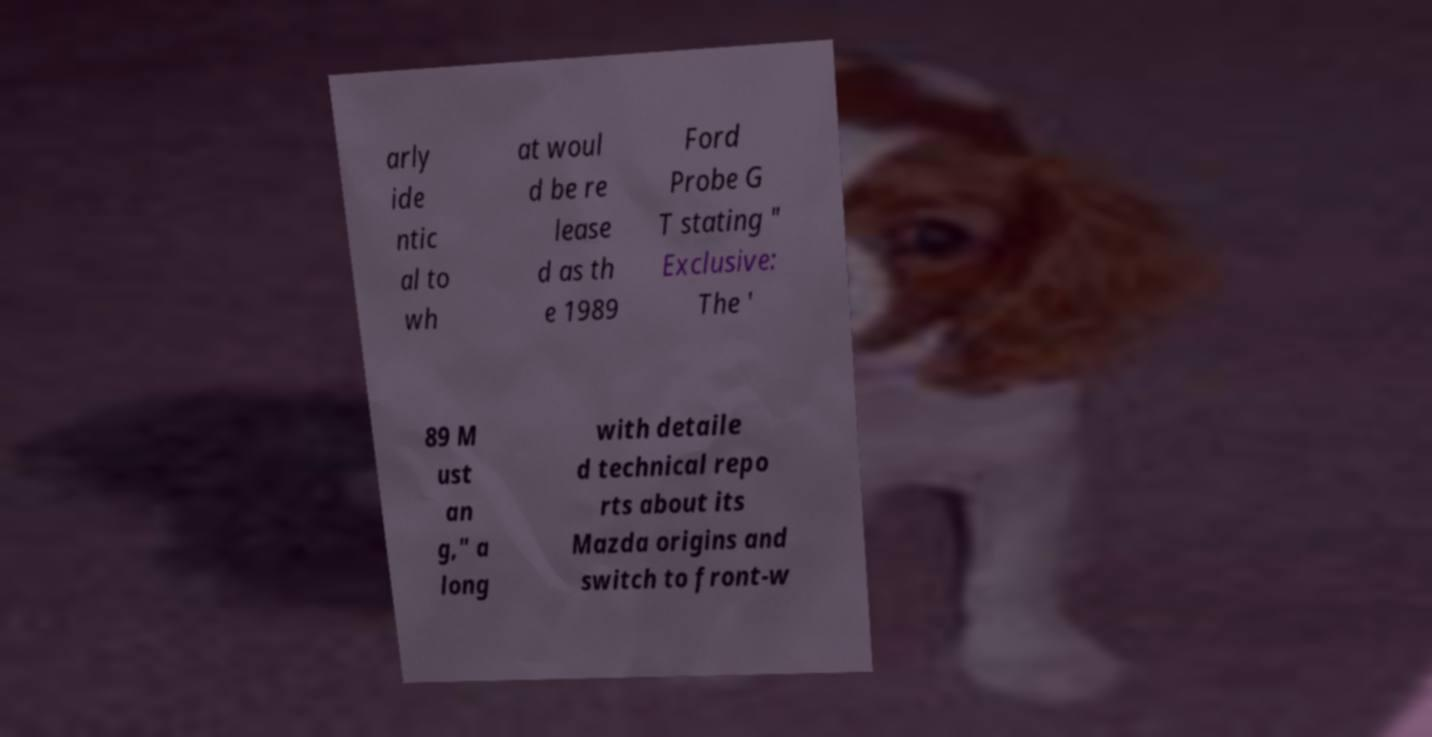For documentation purposes, I need the text within this image transcribed. Could you provide that? arly ide ntic al to wh at woul d be re lease d as th e 1989 Ford Probe G T stating " Exclusive: The ' 89 M ust an g," a long with detaile d technical repo rts about its Mazda origins and switch to front-w 